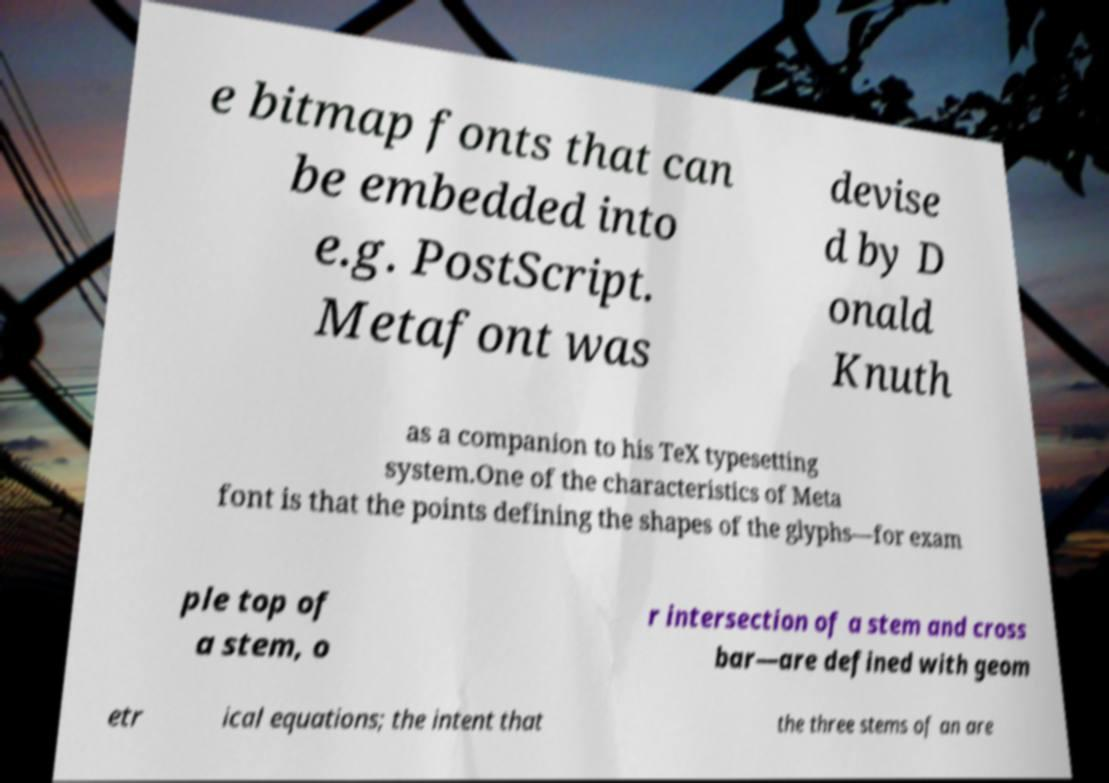Can you read and provide the text displayed in the image?This photo seems to have some interesting text. Can you extract and type it out for me? e bitmap fonts that can be embedded into e.g. PostScript. Metafont was devise d by D onald Knuth as a companion to his TeX typesetting system.One of the characteristics of Meta font is that the points defining the shapes of the glyphs—for exam ple top of a stem, o r intersection of a stem and cross bar—are defined with geom etr ical equations; the intent that the three stems of an are 